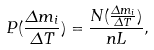Convert formula to latex. <formula><loc_0><loc_0><loc_500><loc_500>P ( \frac { \Delta m _ { i } } { \Delta T } ) = \frac { N ( \frac { \Delta m _ { i } } { \Delta T } ) } { n L } ,</formula> 